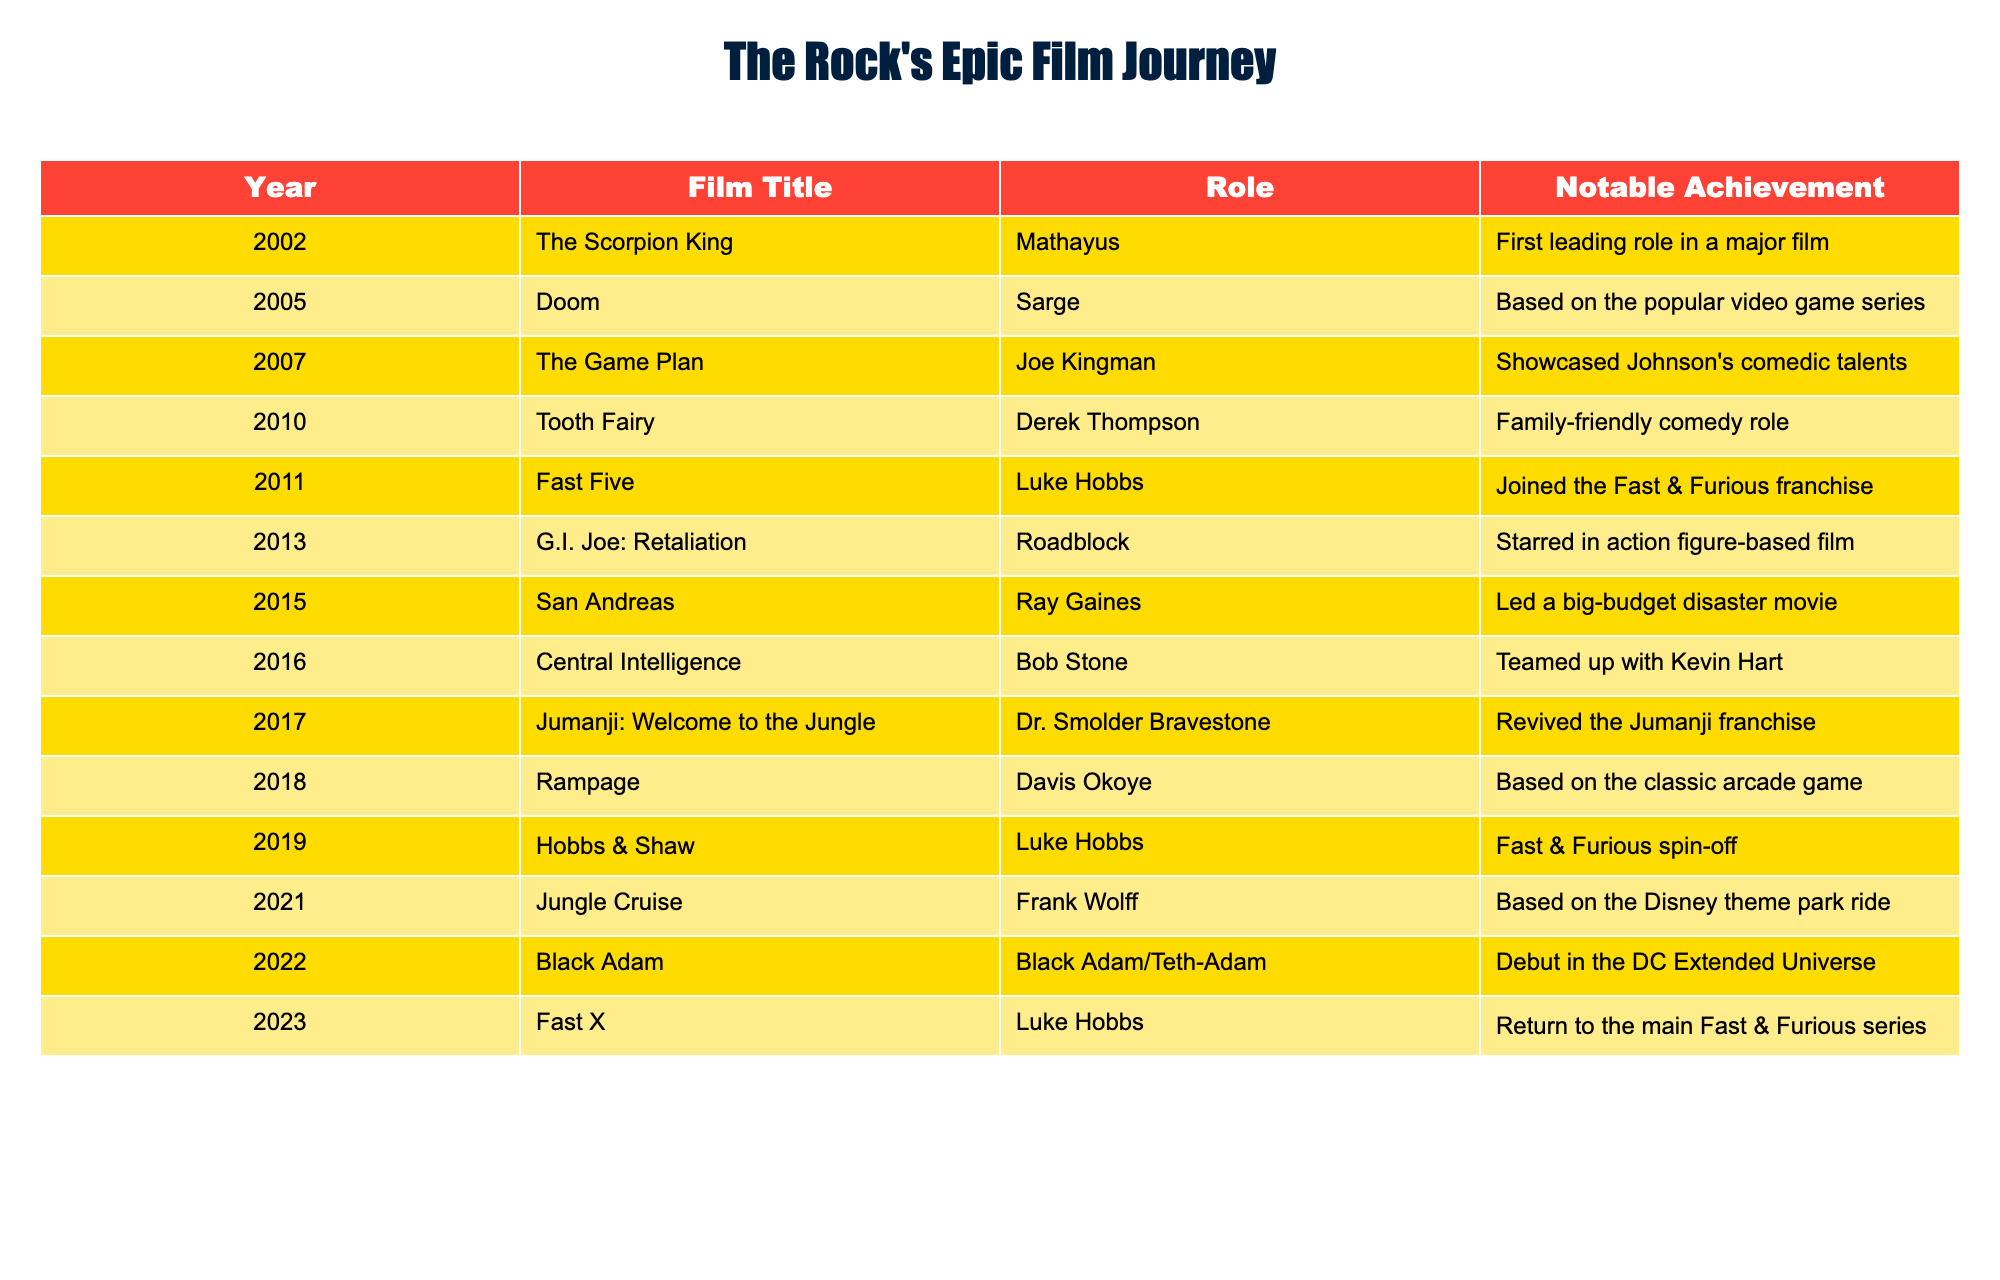What was Dwayne Johnson's first leading role in a film? The table shows that "The Scorpion King" released in 2002 was the first film where Dwayne Johnson played a leading role, as indicated in the "Role" column.
Answer: The Scorpion King Which film showcased Dwayne Johnson's comedic talents? According to the table, "The Game Plan" released in 2007 is noted specifically for showcasing Johnson's comedic talents.
Answer: The Game Plan How many films did Dwayne Johnson release between 2000 and 2023? The table lists 13 films released between 2000 and 2023. By counting each entry in the year column, we confirm the total is 13.
Answer: 13 Did Dwayne Johnson return to the main Fast & Furious series? Yes, according to the table, Dwayne Johnson returned to the Fast & Furious series in the film "Fast X" in 2023, as noted in the "Notable Achievement" column.
Answer: Yes What year did Dwayne Johnson join the Fast & Furious franchise? Referring to the table, Dwayne Johnson joined the Fast & Furious franchise in 2011 with the film "Fast Five," as indicated in the "Year" column.
Answer: 2011 Which two films did Dwayne Johnson release in 2022 and what are their notable achievements? The table indicates that in 2022, Dwayne Johnson released "Black Adam," and it was noted as his debut in the DC Extended Universe, and by referring to the year column, this is confirmed.
Answer: Black Adam In how many films did Dwayne Johnson portray the character Luke Hobbs? By examining the table, Dwayne Johnson portrayed Luke Hobbs in "Fast Five," "Hobbs & Shaw," and "Fast X," totaling three films.
Answer: 3 What was the notable achievement of the film "Jumanji: Welcome to the Jungle"? According to the table, "Jumanji: Welcome to the Jungle" is noted for reviving the Jumanji franchise, indicating its significance in Dwayne Johnson's career.
Answer: Revived the Jumanji franchise How many disaster-themed movies did Dwayne Johnson star in from 2000 to 2023? Referring to the table, "San Andreas" (2015) is listed as a big-budget disaster movie. This indicates that there is only one film explicitly categorized as disaster-themed in this time frame.
Answer: 1 What character did Dwayne Johnson play in "Tooth Fairy"? The table reveals that in the movie "Tooth Fairy," released in 2010, Dwayne Johnson played the character Derek Thompson.
Answer: Derek Thompson 